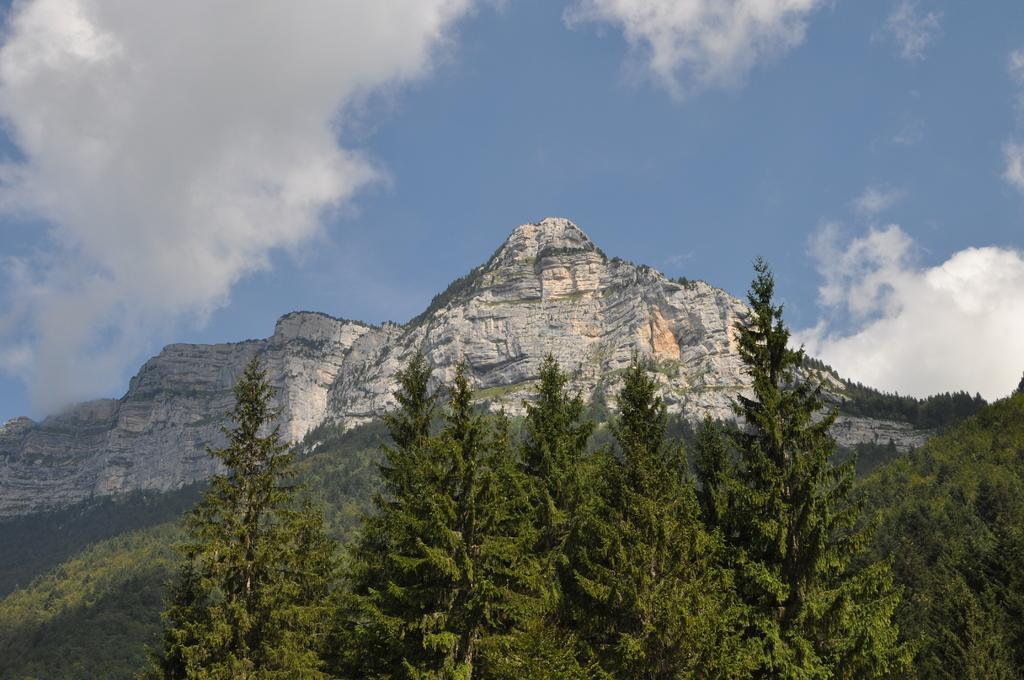What type of vegetation can be seen in the image? There are trees in the image. What type of landscape feature is present in the image? There are hills in the image. What is visible in the sky in the image? There are clouds visible in the image. Where is the throne located in the image? There is no throne present in the image. What trick can be performed with the clouds in the image? There is no trick being performed with the clouds in the image; they are simply visible in the sky. 